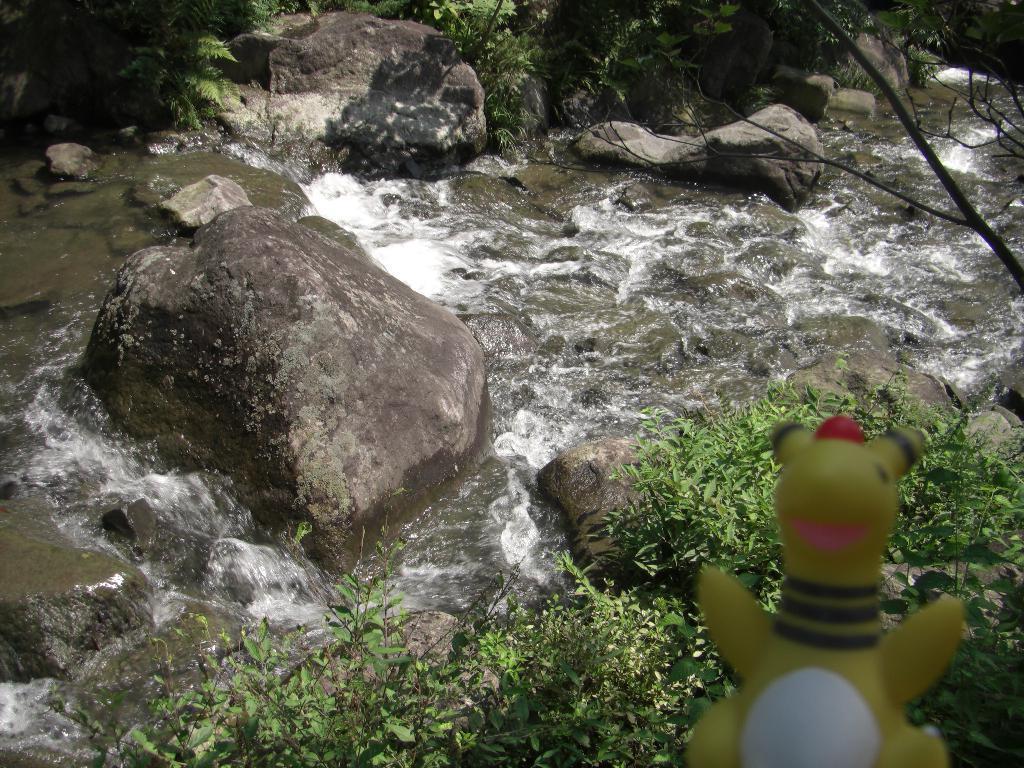Can you describe this image briefly? In the right bottom of the picture, we see a toy in yellow color. Beside that, there are plants. In the middle of the picture, we see water flowing. We even see the rocks. There are trees in the background. 